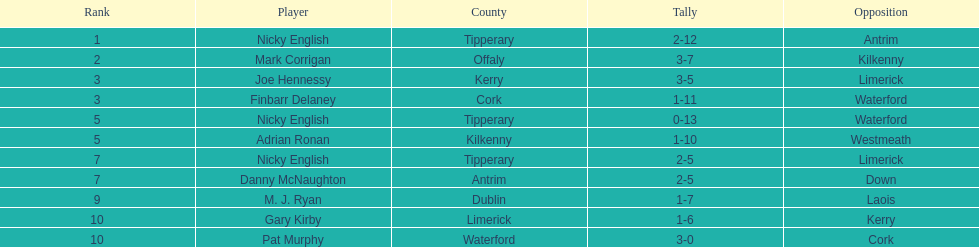Would you be able to parse every entry in this table? {'header': ['Rank', 'Player', 'County', 'Tally', 'Opposition'], 'rows': [['1', 'Nicky English', 'Tipperary', '2-12', 'Antrim'], ['2', 'Mark Corrigan', 'Offaly', '3-7', 'Kilkenny'], ['3', 'Joe Hennessy', 'Kerry', '3-5', 'Limerick'], ['3', 'Finbarr Delaney', 'Cork', '1-11', 'Waterford'], ['5', 'Nicky English', 'Tipperary', '0-13', 'Waterford'], ['5', 'Adrian Ronan', 'Kilkenny', '1-10', 'Westmeath'], ['7', 'Nicky English', 'Tipperary', '2-5', 'Limerick'], ['7', 'Danny McNaughton', 'Antrim', '2-5', 'Down'], ['9', 'M. J. Ryan', 'Dublin', '1-7', 'Laois'], ['10', 'Gary Kirby', 'Limerick', '1-6', 'Kerry'], ['10', 'Pat Murphy', 'Waterford', '3-0', 'Cork']]} How many points did joe hennessy and finbarr delaney each score? 14. 